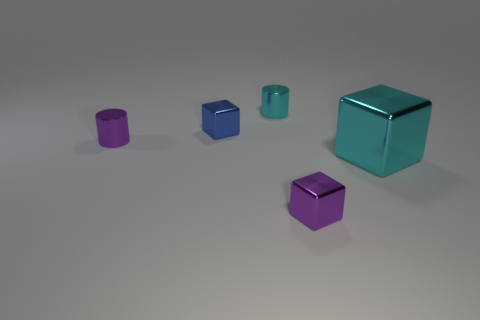What number of other things are the same color as the large metal object?
Offer a terse response. 1. What size is the cylinder that is the same color as the big shiny thing?
Your response must be concise. Small. What size is the cyan cylinder that is the same material as the tiny purple cylinder?
Offer a terse response. Small. There is a tiny blue metallic object; are there any blue metallic things to the right of it?
Your answer should be very brief. No. The purple metallic thing that is the same shape as the big cyan thing is what size?
Your answer should be very brief. Small. There is a big metal object; does it have the same color as the cylinder right of the purple metal cylinder?
Your response must be concise. Yes. Is the number of cyan objects less than the number of tiny cyan cylinders?
Your answer should be very brief. No. How many other things are there of the same color as the big block?
Your answer should be compact. 1. What number of tiny cubes are there?
Your answer should be compact. 2. Are there fewer small purple blocks that are in front of the tiny cyan cylinder than big gray rubber cylinders?
Your response must be concise. No. 